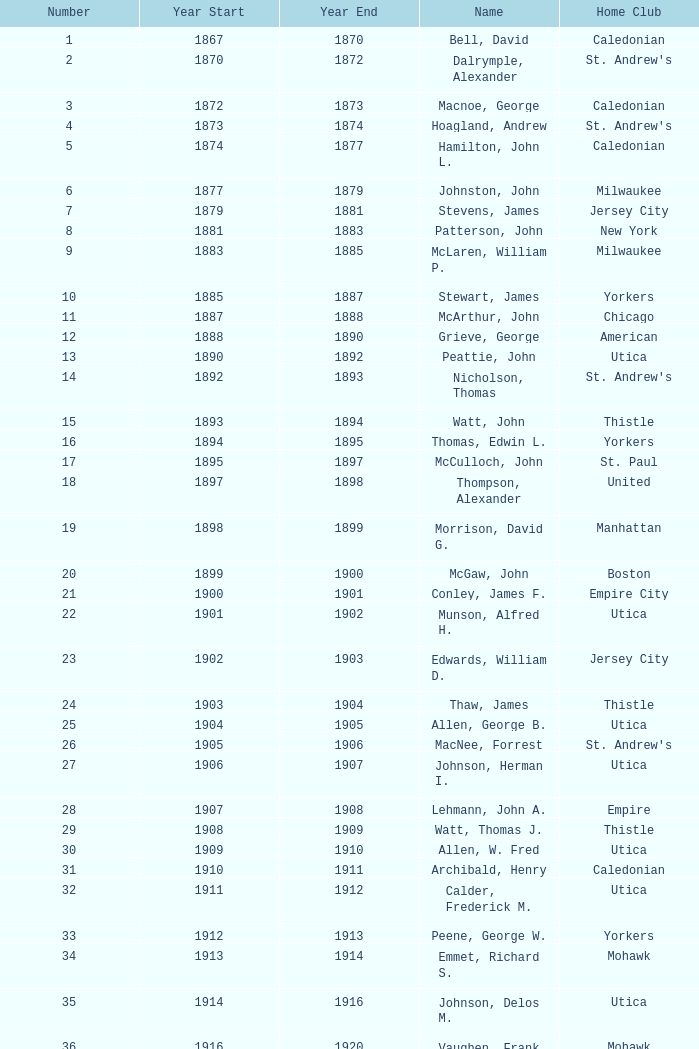Which Number has a Name of hill, lucius t.? 53.0. 